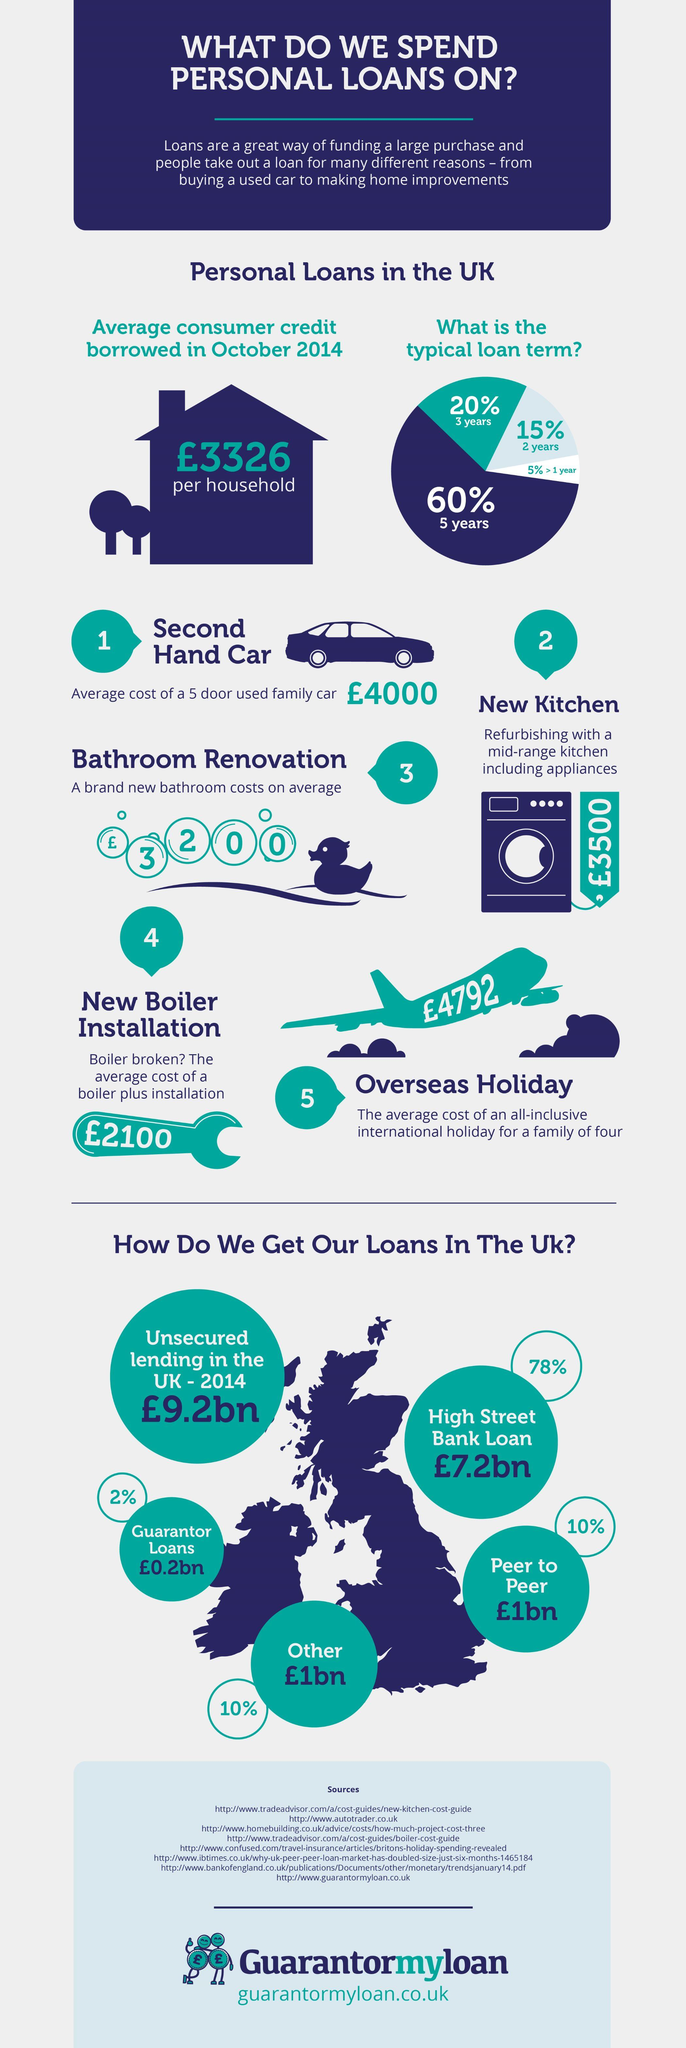Specify some key components in this picture. Approximately 60% of loans taken have a five-year term. The cost of installing a new boiler in pounds would be approximately 2100. Based on the image, it is clear that a second-hand car can be obtained for approximately £4000. The major source of loans in the UK is High Street Banks. The estimated cost of refurbishing a kitchen is 3500 pounds. 